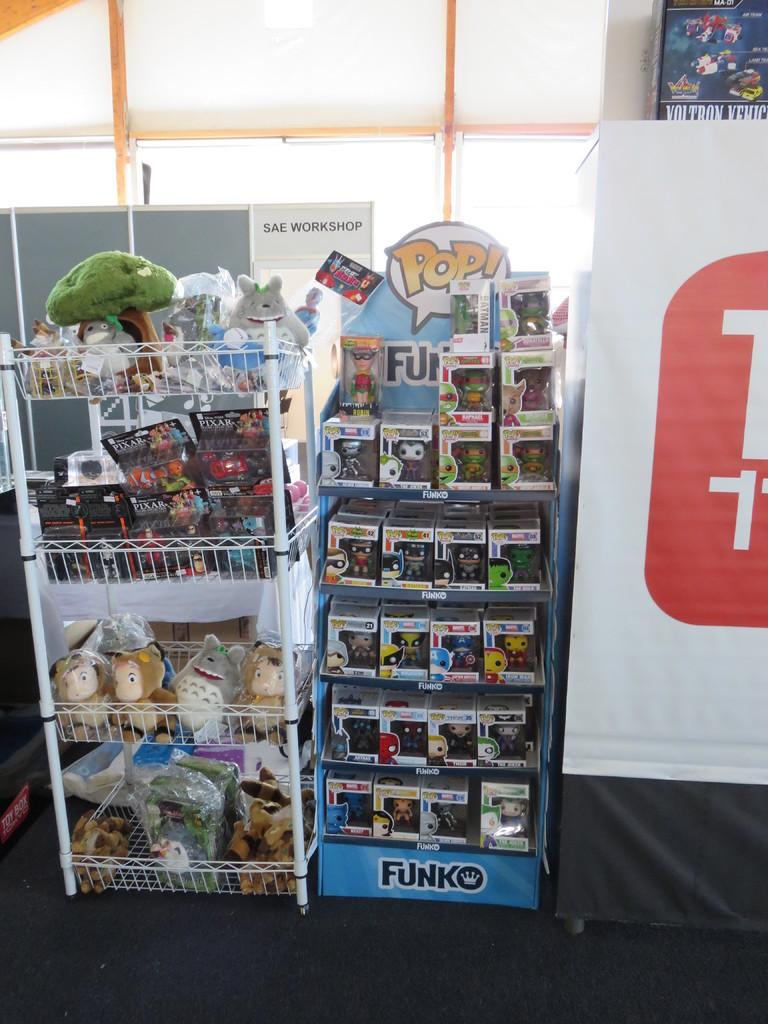How many racks can be seen in the image? There are two racks in the image. What is the purpose of the racks in the image? The racks are used to hold objects. Can you describe the poster on the right side of the image? There is a white color poster on the right side of the image. What type of friction is being generated by the objects on the racks? There is no information about friction in the image, as it focuses on the racks and the objects on them. --- Facts: 1. There is a person sitting on a chair in the image. 2. The person is holding a book. 3. There is a table next to the chair. 4. There is a lamp on the table. Absurd Topics: parrot, ocean, dance Conversation: What is the person in the image doing? The person is sitting on a chair in the image. What is the person holding in the image? The person is holding a book. What is located next to the chair in the image? There is a table next to the chair in the image. What object is on the table in the image? There is a lamp on the table in the image. Reasoning: Let's think step by step in order to produce the conversation. We start by identifying the main subject in the image, which is the person sitting on a chair. Then, we describe what the person is holding, which is a book. Next, we mention the presence of the table next to the chair. Finally, we identify the object on the table, which is a lamp. Each question is designed to elicit a specific detail about the image that is known from the provided facts. Absurd Question/Answer: Can you see a parrot dancing on the ocean in the image? No, there is no parrot or ocean present in the image. 